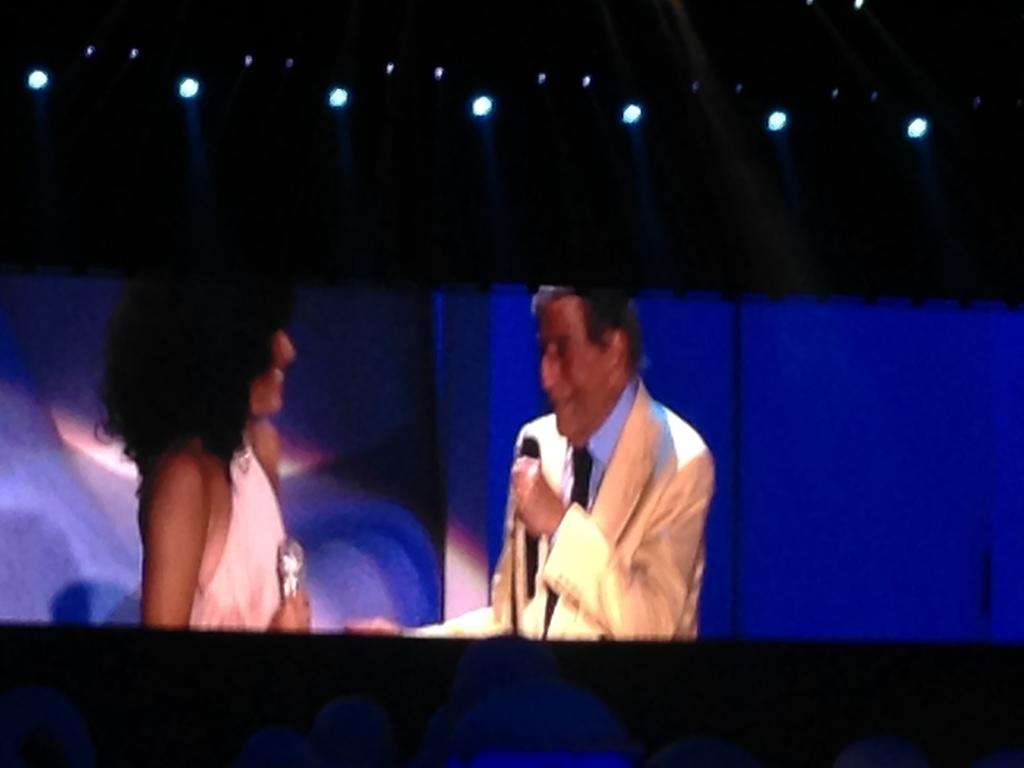What is the main object in the image? There is a screen in the image. What can be seen on the screen? A man is visible on the screen. What is the man holding in his hand? The man is holding a mic in his hand. Who else is present in the image besides the man on the screen? There is a woman in the image. What type of brass instrument is the man playing on the screen? The man is not playing a brass instrument on the screen; he is holding a mic. How many fangs can be seen on the woman in the image? There are no fangs visible on the woman in the image. 